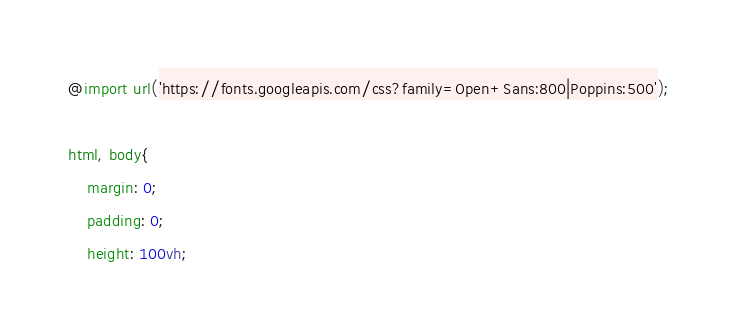<code> <loc_0><loc_0><loc_500><loc_500><_CSS_>@import url('https://fonts.googleapis.com/css?family=Open+Sans:800|Poppins:500');

html, body{
    margin: 0;
    padding: 0;
    height: 100vh;</code> 